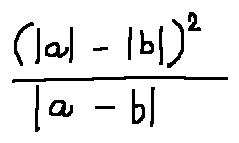<formula> <loc_0><loc_0><loc_500><loc_500>\frac { ( | a | - | b | ) ^ { 2 } } { | a - b | }</formula> 